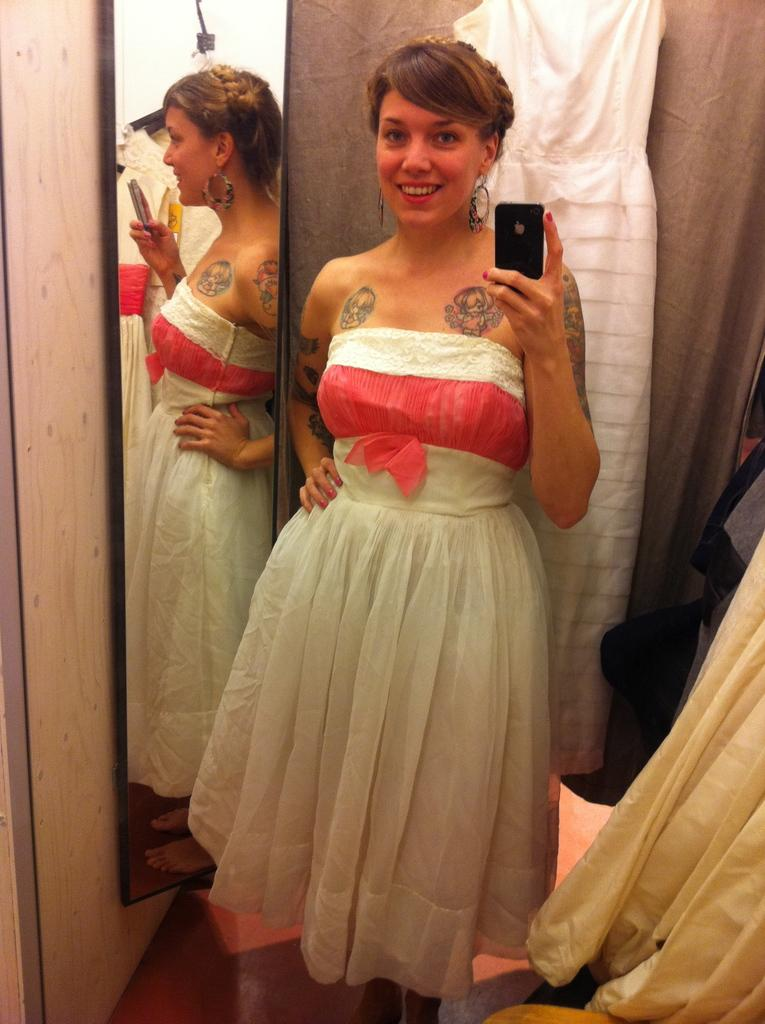Who is the main subject in the image? There is a woman in the image. What is the woman wearing? The woman is wearing a white gown. What is the woman doing in the image? The woman is taking a picture. What can be seen on the left side of the woman? There is a mirror on the left side of the woman. What is hanging on the wall behind the woman? There are dresses hanging on the wall behind the woman. What type of harmony can be heard in the background of the image? There is no audible sound or music present in the image, so it is not possible to determine the type of harmony. 